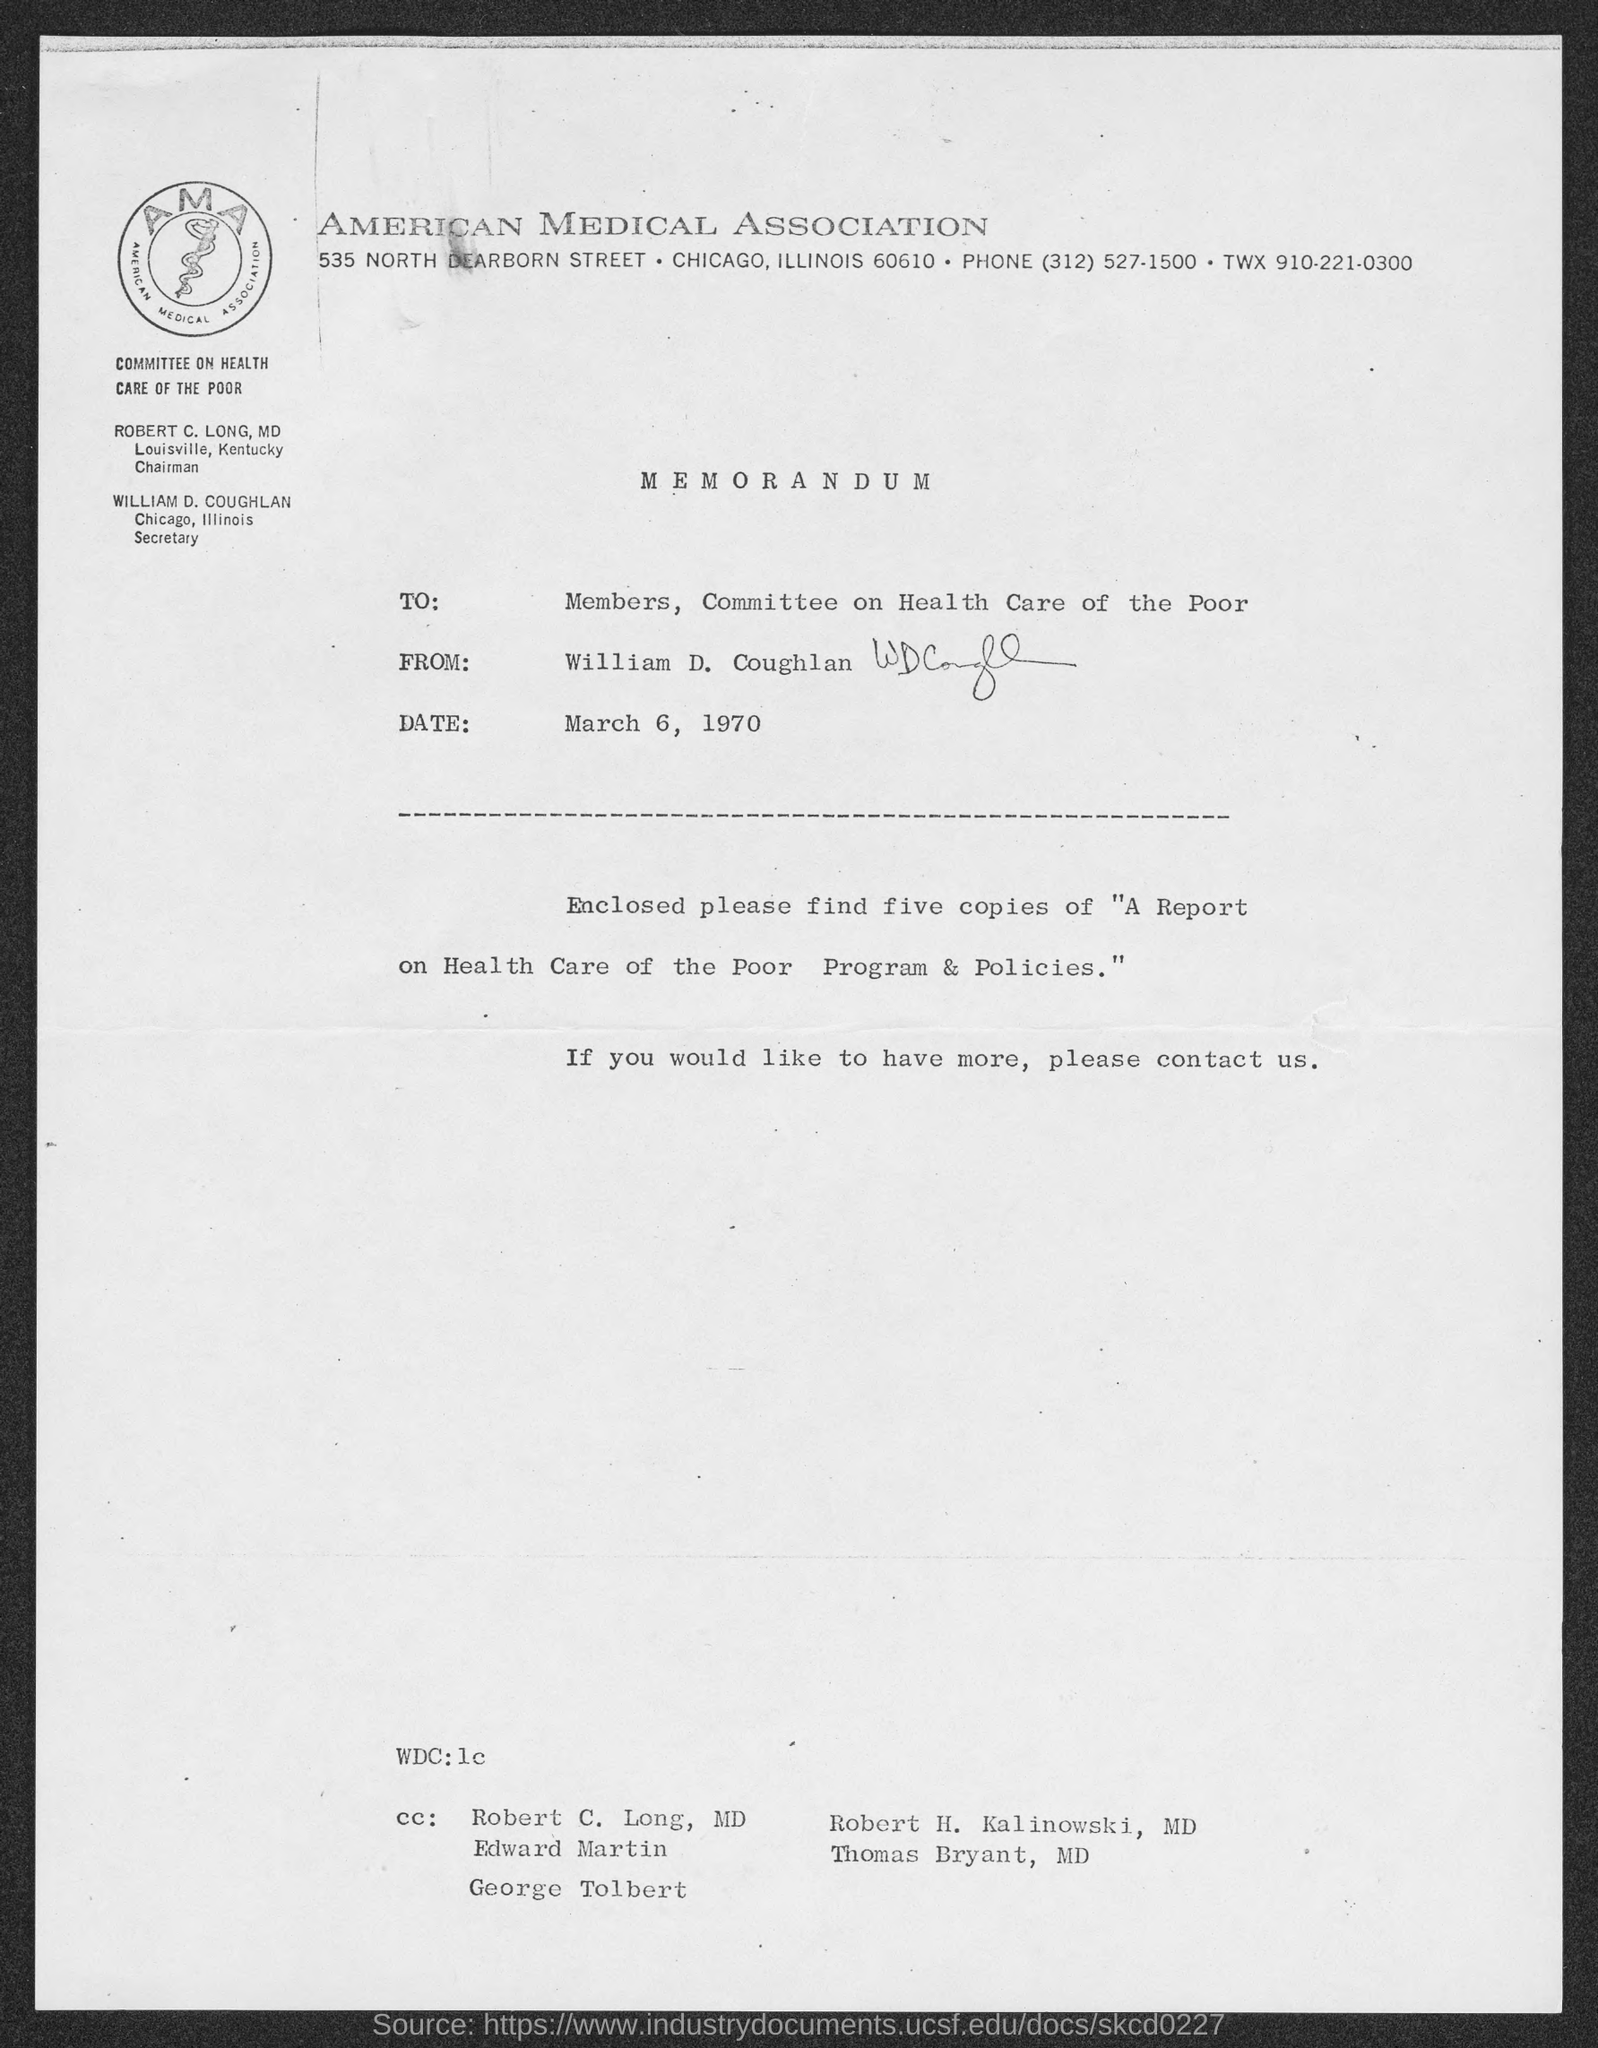What is the date mentioned in Memorandum?
Keep it short and to the point. March 6, 1970. Who is the Chairman of Committee On Health Care Of The Poor?
Provide a short and direct response. ROBERT C. LONG, MD. 